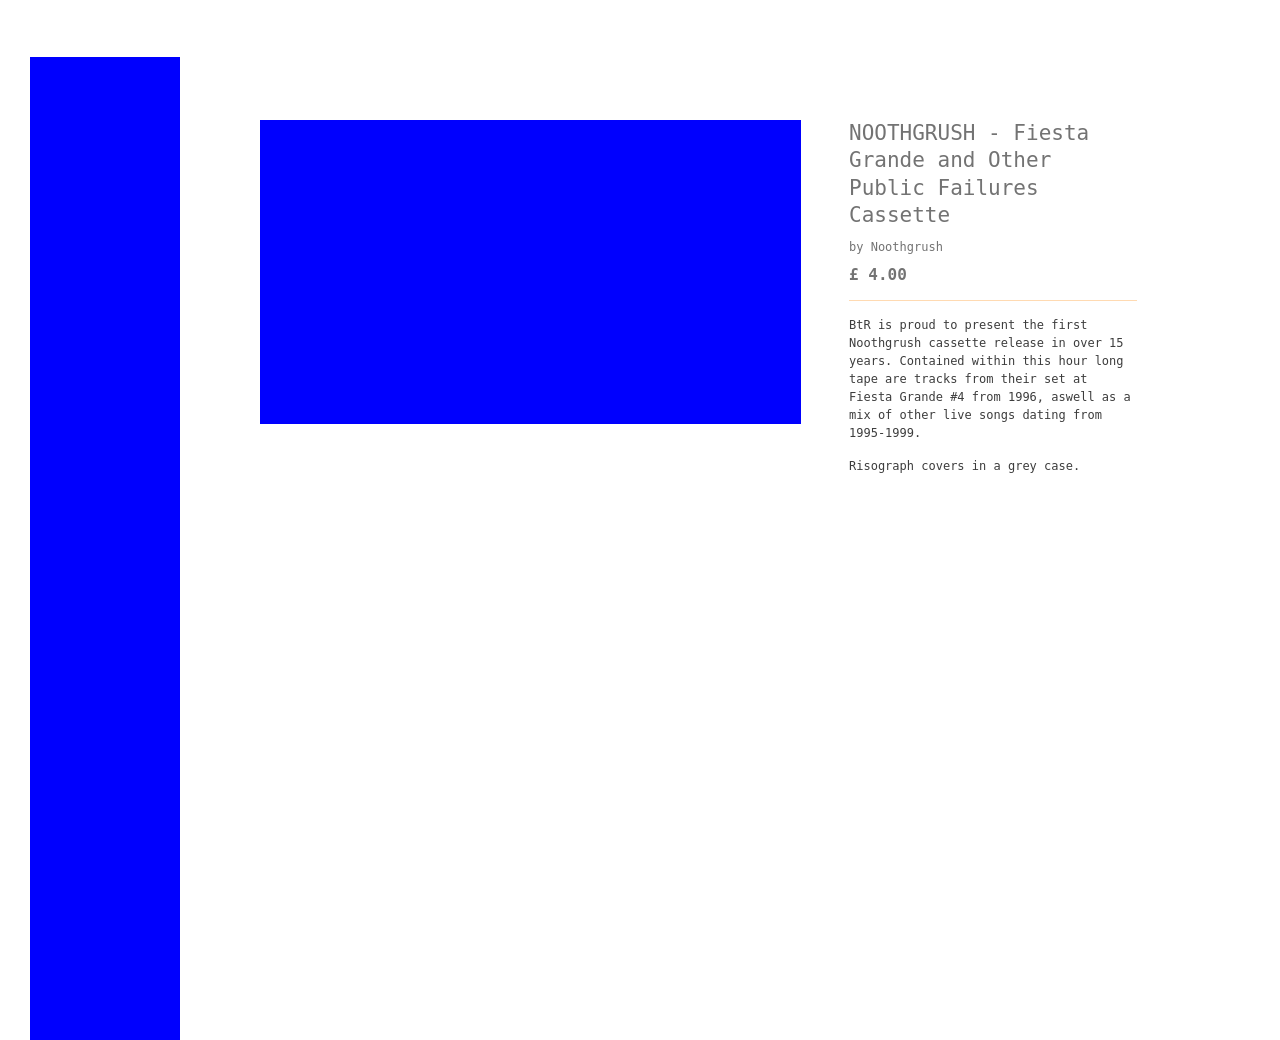What does the text on this promotional cassette cover tell us about the music genre and its audience? The text describes it as a collection from Noothgrush's performances, indicating a likely genre of doom metal or sludge metal, known for their heavy and slow musical style. The target audience appears to be fans of underground music and collectors of rare music recordings, emphasizing the cassette format and the historical significance of the live performances. 
How do cassette releases like this influence the perception of a band's music? Cassette releases, especially of live performances, often contribute to a band's perception as authentic and deeply connected with the grassroots of their genre. They can create a nostalgic, raw, and real experience, appealing to both long-time followers and new listeners who value the tangible and artisanal aspect of music consumption. This format can help in cultivating a niche but dedicated fanbase. 